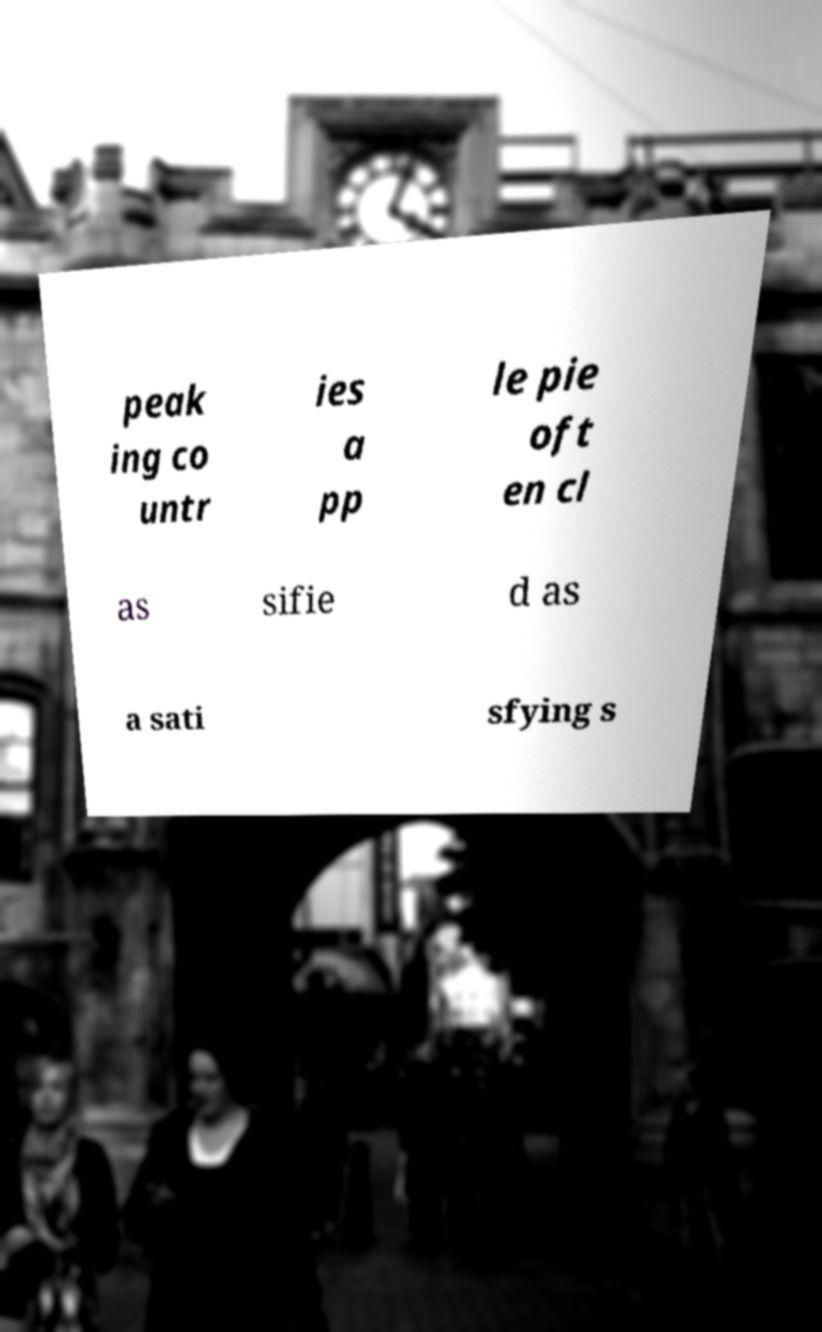There's text embedded in this image that I need extracted. Can you transcribe it verbatim? peak ing co untr ies a pp le pie oft en cl as sifie d as a sati sfying s 